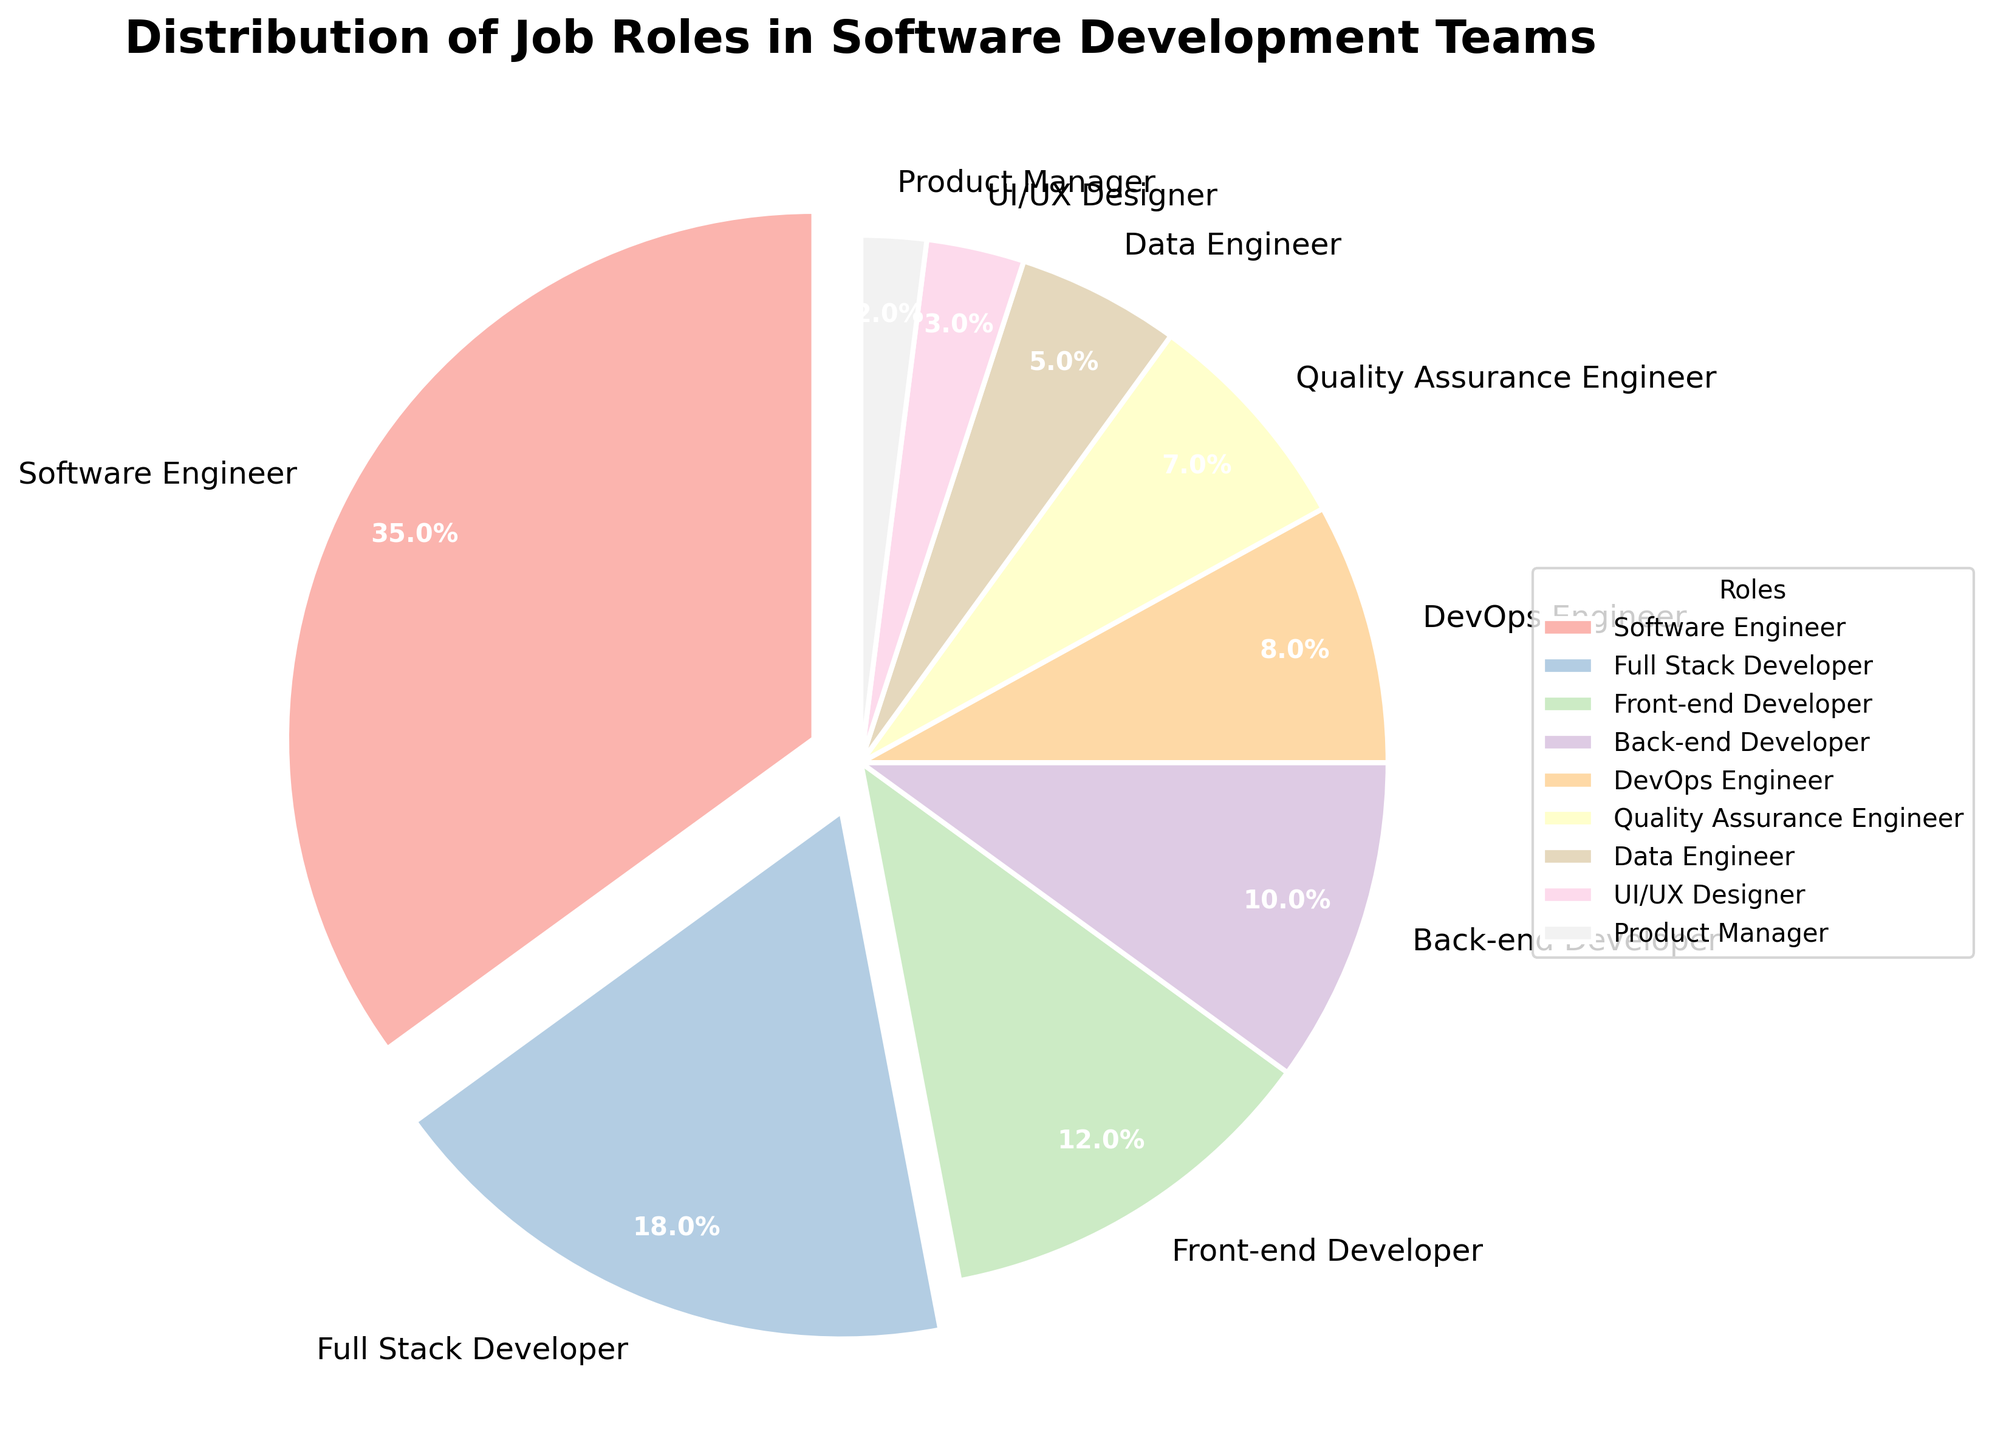Which role has the highest percentage in the distribution? The figure shows the percentage distribution of various job roles in software development teams. By observing the segments of the pie chart, we can see that Software Engineer has the largest segment.
Answer: Software Engineer What is the combined percentage of Front-end Developer and Back-end Developer roles? The percentages for Front-end Developer and Back-end Developer are 12% and 10%, respectively. Adding them together gives 12 + 10 = 22%.
Answer: 22% Which two roles have percentages greater than 15%, and what is their combined percentage? Observing the figure, Software Engineer and Full Stack Developer are the two roles with segments exploded, indicating they have percentages greater than 15%. Their percentages are 35% and 18%, respectively. Adding them together gives 35 + 18 = 53%.
Answer: Software Engineer and Full Stack Developer, 53% How much larger is the percentage of Software Engineers compared to DevOps Engineers? The percentage for Software Engineers is 35%, and for DevOps Engineers, it is 8%. Subtracting the smaller percentage from the larger gives 35 - 8 = 27%.
Answer: 27% Which role has the smallest percentage, and what is that percentage? The pie chart shows that the smallest segment corresponds to the Product Manager role. The percentage for Product Manager is 2%.
Answer: Product Manager, 2% What is the percentage difference between Data Engineers and Front-end Developers? Data Engineers have a percentage of 5%, while Front-end Developers have 12%. Subtracting the smaller percentage from the larger gives 12 - 5 = 7%.
Answer: 7% List the roles in descending order of their percentages. Observing the pie chart, the roles from the largest to the smallest segment are: Software Engineer (35%), Full Stack Developer (18%), Front-end Developer (12%), Back-end Developer (10%), DevOps Engineer (8%), Quality Assurance Engineer (7%), Data Engineer (5%), UI/UX Designer (3%), Product Manager (2%).
Answer: Software Engineer, Full Stack Developer, Front-end Developer, Back-end Developer, DevOps Engineer, Quality Assurance Engineer, Data Engineer, UI/UX Designer, Product Manager What is the combined percentage of all roles labeled with segments pulled out (exploded)? The exploded segments indicate higher percentages. Observing the pie chart, these segments are Software Engineer (35%) and Full Stack Developer (18%). Adding them together gives 35 + 18 = 53%.
Answer: 53% Which role segment is colored light green, and what is its percentage? The pie chart uses colors that transition smoothly. Observing the legend and the pie wedges, the light green segment corresponds to the Back-end Developer role with a percentage of 10%.
Answer: Back-end Developer, 10% How does the percentage of UI/UX Designers compare to that of Product Managers? In the pie chart, the percentage for UI/UX Designers is 3%, whereas for Product Managers, it is 2%. Comparing these values, UI/UX Designers have a 1% larger percentage than Product Managers.
Answer: 1% larger 